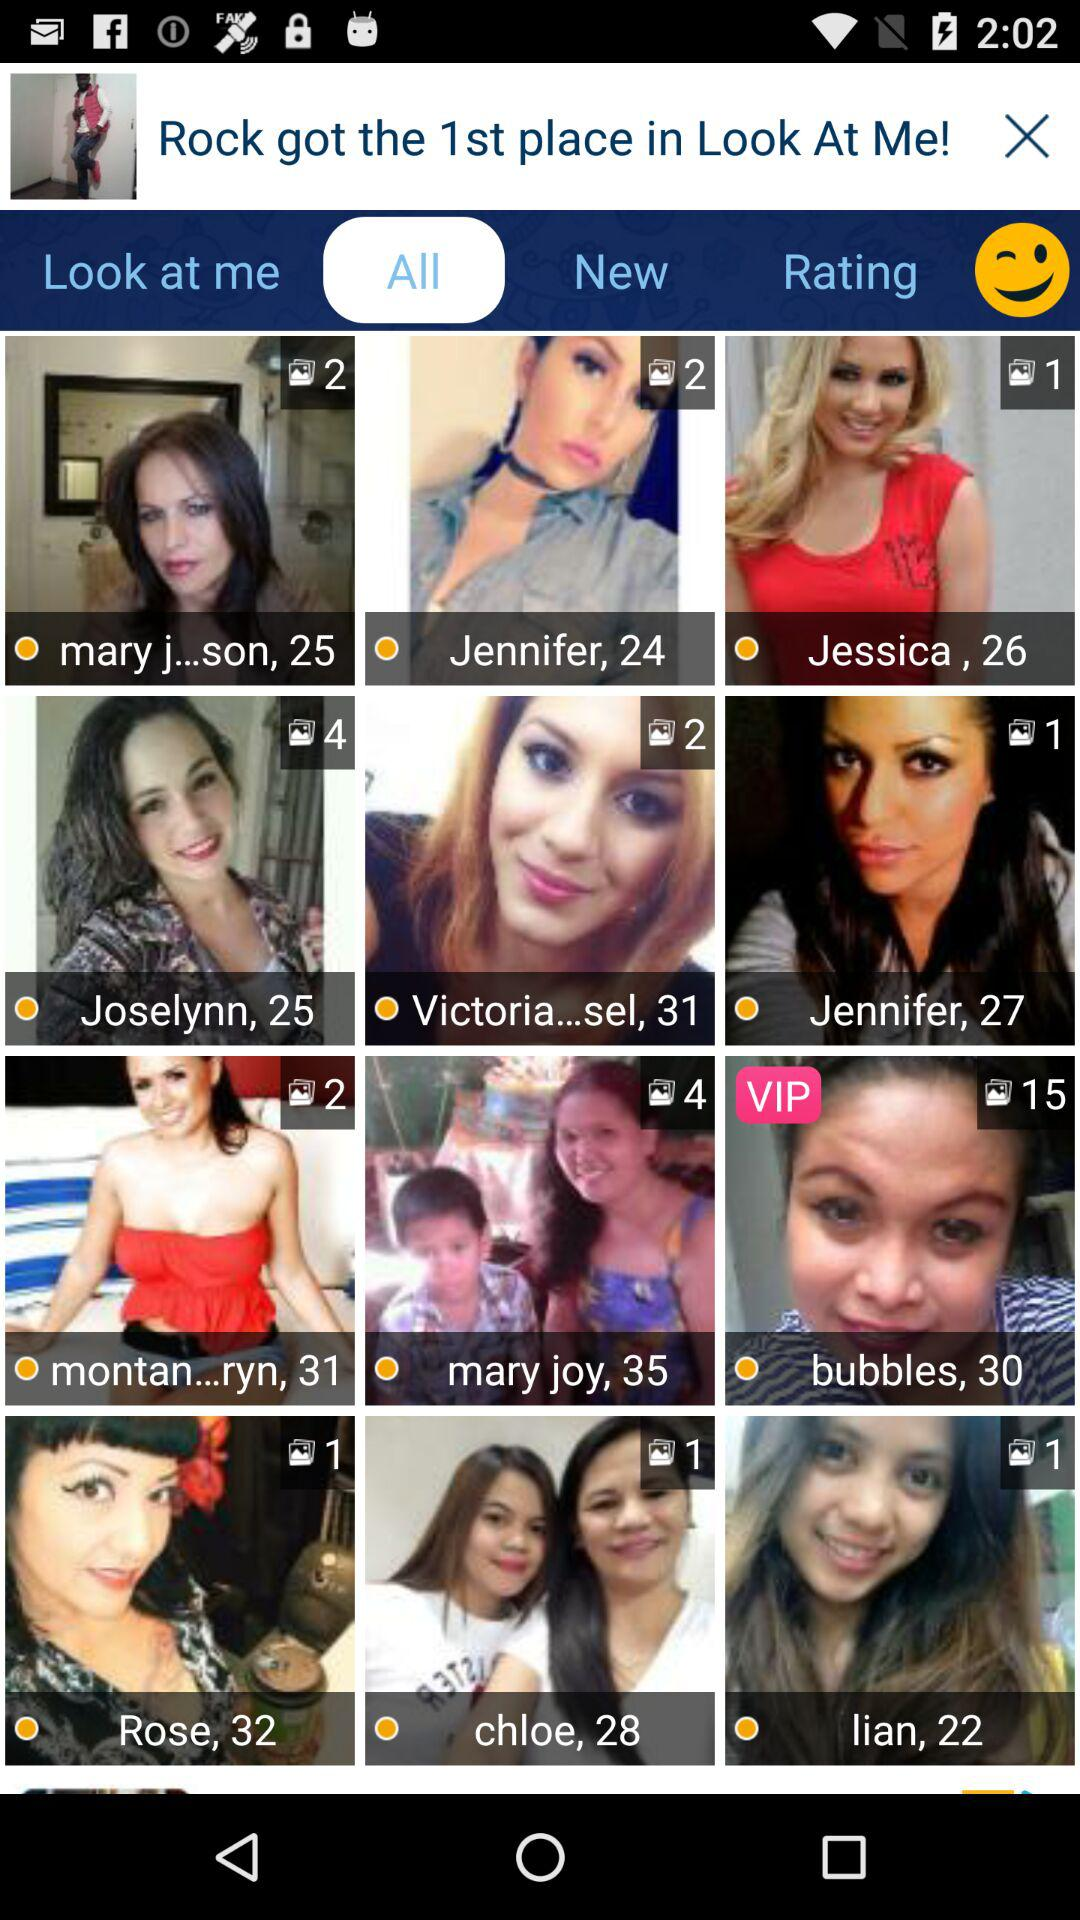What is the age of Rose? Rose is 32 years old. 